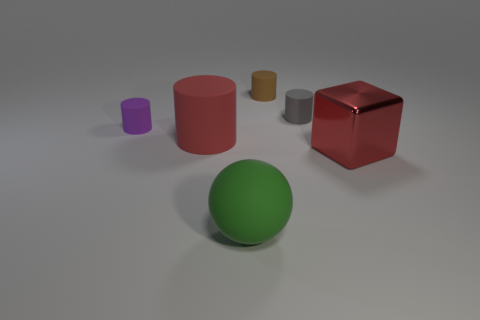How many green things are rubber spheres or large shiny cubes? In the image, there is one green rubber sphere present, but there are no large shiny cubes, green or otherwise. Therefore, the total count of green things that are either rubber spheres or large shiny cubes is one. 